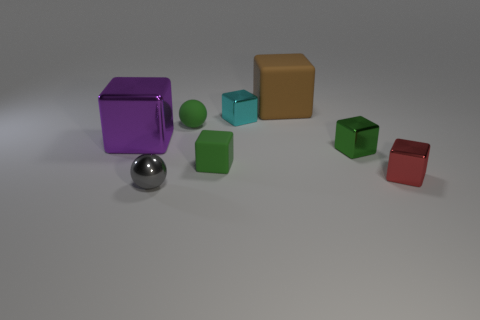Subtract all green balls. How many green cubes are left? 2 Subtract all big brown matte blocks. How many blocks are left? 5 Subtract 1 cubes. How many cubes are left? 5 Subtract all green cubes. How many cubes are left? 4 Subtract all purple blocks. Subtract all blue cylinders. How many blocks are left? 5 Add 2 brown things. How many objects exist? 10 Subtract all cubes. How many objects are left? 2 Add 2 brown matte things. How many brown matte things are left? 3 Add 8 tiny rubber cubes. How many tiny rubber cubes exist? 9 Subtract 0 purple cylinders. How many objects are left? 8 